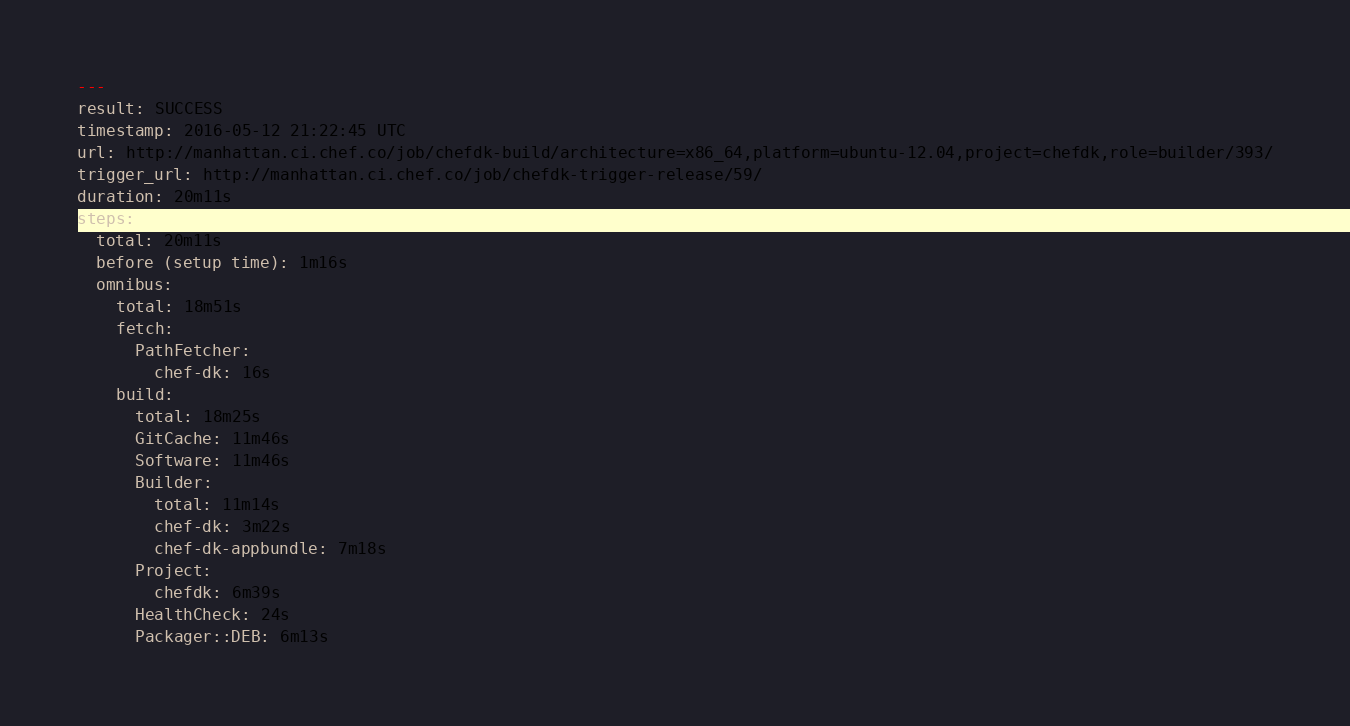Convert code to text. <code><loc_0><loc_0><loc_500><loc_500><_YAML_>---
result: SUCCESS
timestamp: 2016-05-12 21:22:45 UTC
url: http://manhattan.ci.chef.co/job/chefdk-build/architecture=x86_64,platform=ubuntu-12.04,project=chefdk,role=builder/393/
trigger_url: http://manhattan.ci.chef.co/job/chefdk-trigger-release/59/
duration: 20m11s
steps:
  total: 20m11s
  before (setup time): 1m16s
  omnibus:
    total: 18m51s
    fetch:
      PathFetcher:
        chef-dk: 16s
    build:
      total: 18m25s
      GitCache: 11m46s
      Software: 11m46s
      Builder:
        total: 11m14s
        chef-dk: 3m22s
        chef-dk-appbundle: 7m18s
      Project:
        chefdk: 6m39s
      HealthCheck: 24s
      Packager::DEB: 6m13s
</code> 